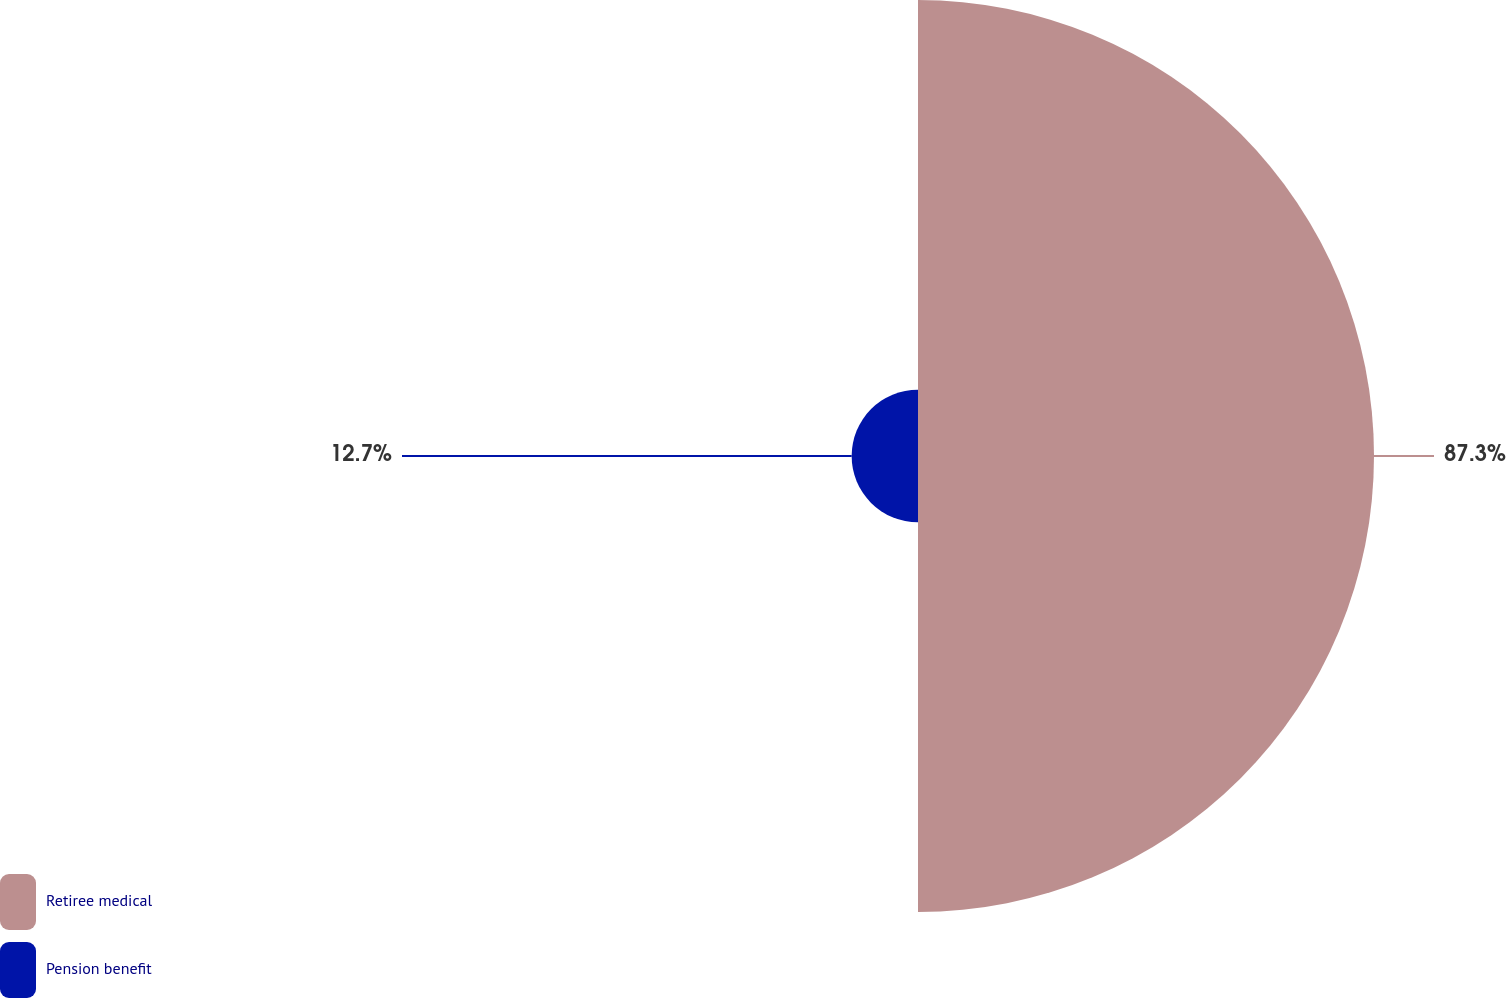Convert chart to OTSL. <chart><loc_0><loc_0><loc_500><loc_500><pie_chart><fcel>Retiree medical<fcel>Pension benefit<nl><fcel>87.3%<fcel>12.7%<nl></chart> 